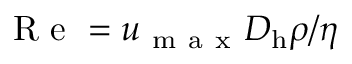<formula> <loc_0><loc_0><loc_500><loc_500>R e = { u _ { m a x } D _ { h } \rho } / { \eta }</formula> 